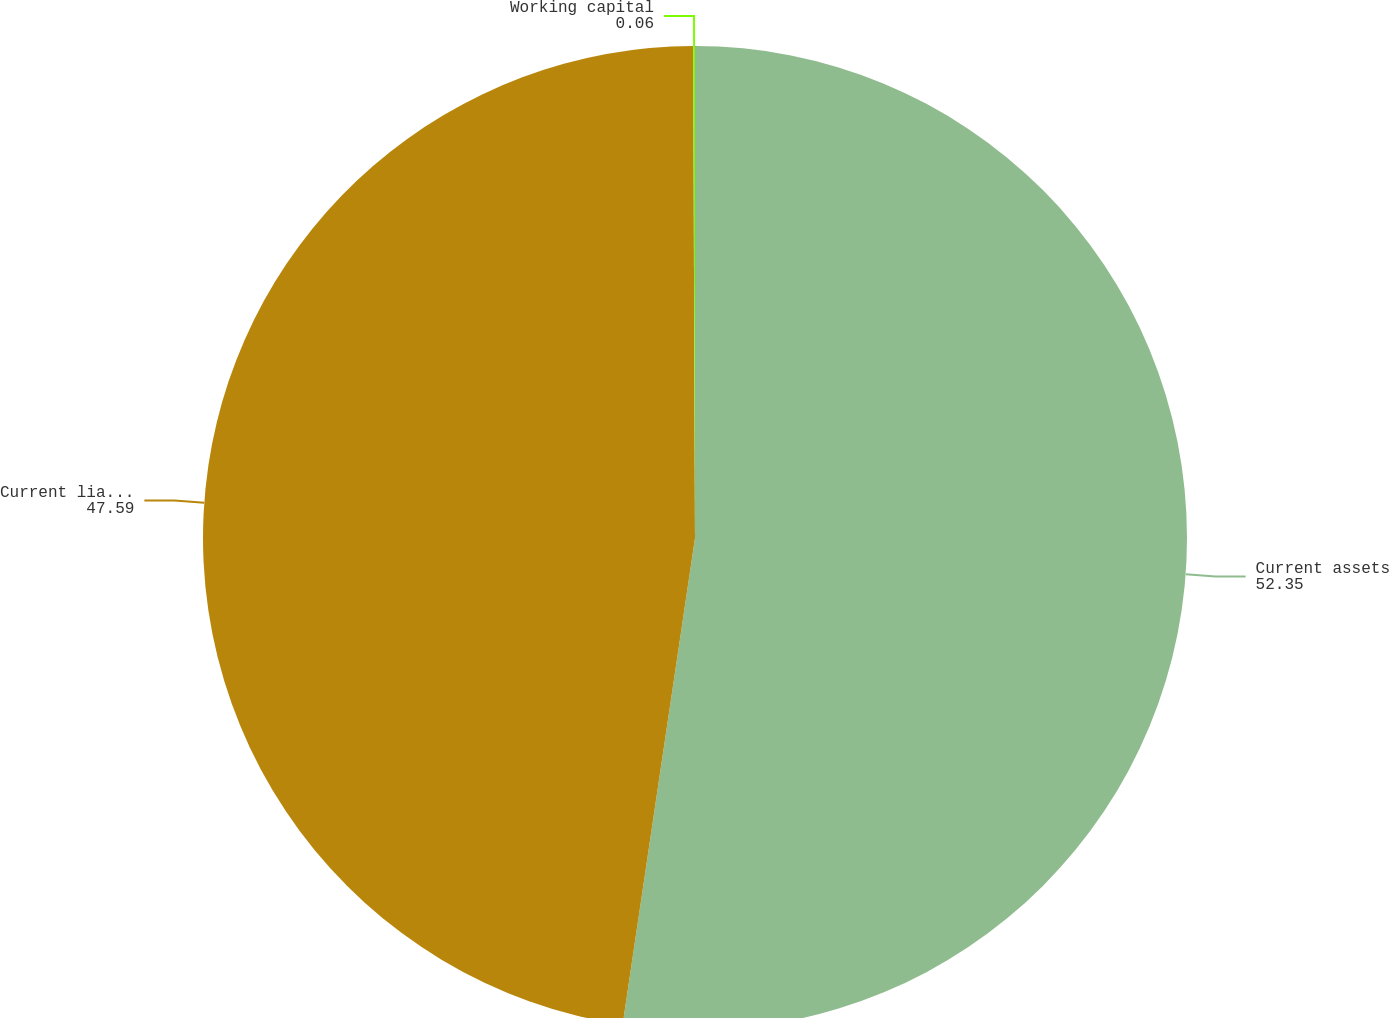Convert chart. <chart><loc_0><loc_0><loc_500><loc_500><pie_chart><fcel>Current assets<fcel>Current liabilities<fcel>Working capital<nl><fcel>52.35%<fcel>47.59%<fcel>0.06%<nl></chart> 